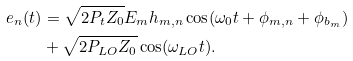<formula> <loc_0><loc_0><loc_500><loc_500>e _ { n } ( t ) & = \sqrt { 2 P _ { t } Z _ { 0 } } E _ { m } h _ { m , n } \cos ( \omega _ { 0 } t + \phi _ { m , n } + \phi _ { b _ { m } } ) \\ & + \sqrt { 2 P _ { L O } Z _ { 0 } } \cos ( \omega _ { L O } t ) .</formula> 